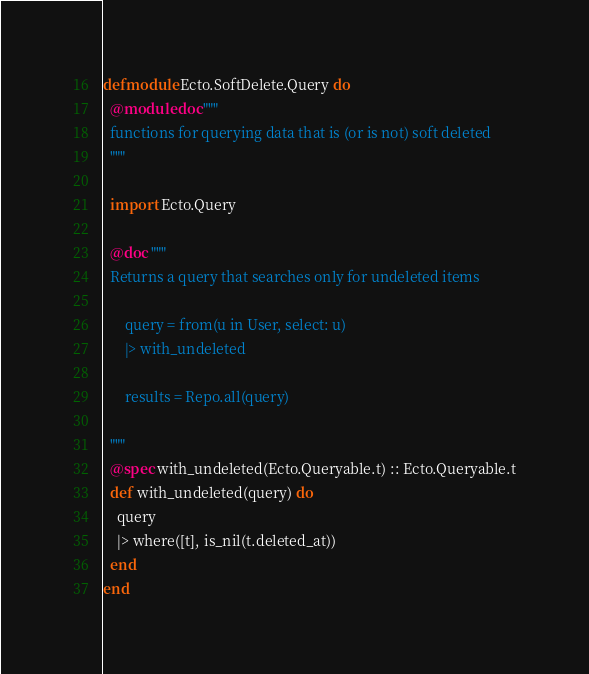<code> <loc_0><loc_0><loc_500><loc_500><_Elixir_>defmodule Ecto.SoftDelete.Query do
  @moduledoc """
  functions for querying data that is (or is not) soft deleted
  """

  import Ecto.Query

  @doc """
  Returns a query that searches only for undeleted items

      query = from(u in User, select: u)
      |> with_undeleted

      results = Repo.all(query)

  """
  @spec with_undeleted(Ecto.Queryable.t) :: Ecto.Queryable.t
  def with_undeleted(query) do
    query
    |> where([t], is_nil(t.deleted_at))
  end
end
</code> 